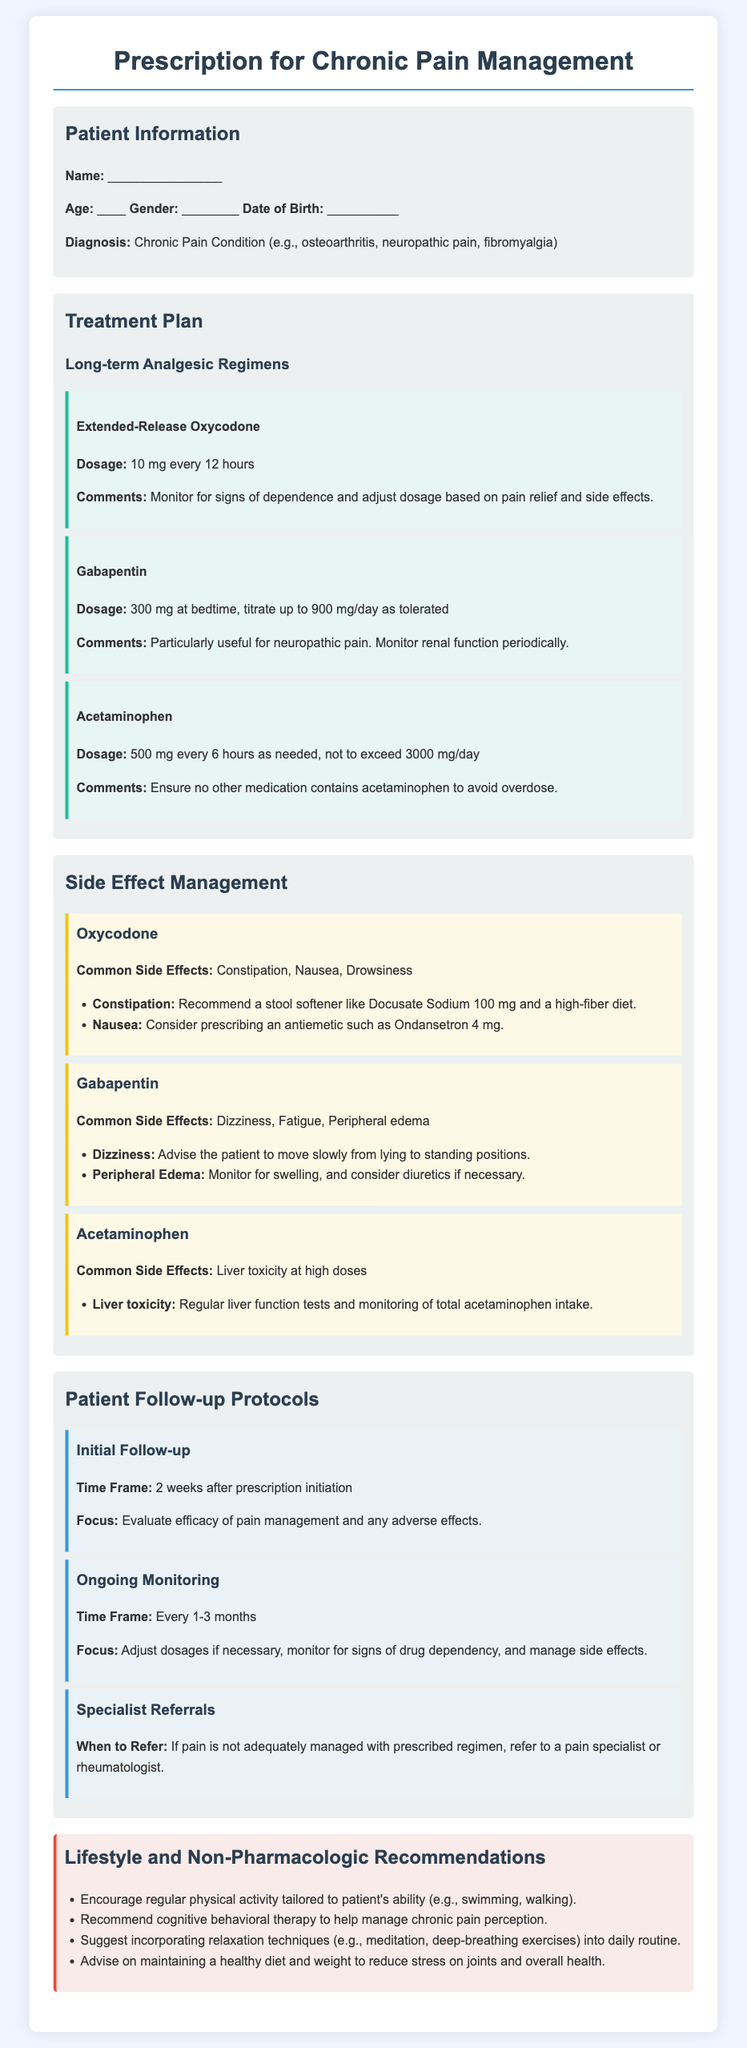What is the dosage for Extended-Release Oxycodone? The dosage for Extended-Release Oxycodone is mentioned as 10 mg every 12 hours in the document.
Answer: 10 mg every 12 hours What are the common side effects of Gabapentin? The common side effects of Gabapentin listed in the document are dizziness, fatigue, and peripheral edema.
Answer: Dizziness, Fatigue, Peripheral edema When is the initial follow-up scheduled? The initial follow-up time frame is specified as 2 weeks after prescription initiation in the document.
Answer: 2 weeks What is the maximum daily dosage for Acetaminophen? The document states that the maximum daily dosage for Acetaminophen should not exceed 3000 mg.
Answer: 3000 mg What non-pharmacologic recommendation involves mental health? The document advises recommending cognitive behavioral therapy to help manage chronic pain perception.
Answer: Cognitive behavioral therapy What medication is particularly useful for neuropathic pain? Gabapentin is mentioned in the document as particularly useful for neuropathic pain.
Answer: Gabapentin What should be monitored when prescribing Oxycodone? The document highlights the need to monitor for signs of dependence and adjust dosage based on pain relief and side effects.
Answer: Signs of dependence When should a patient be referred to a specialist? The document indicates that a patient should be referred to a specialist if pain is not adequately managed with the prescribed regimen.
Answer: Not adequately managed 